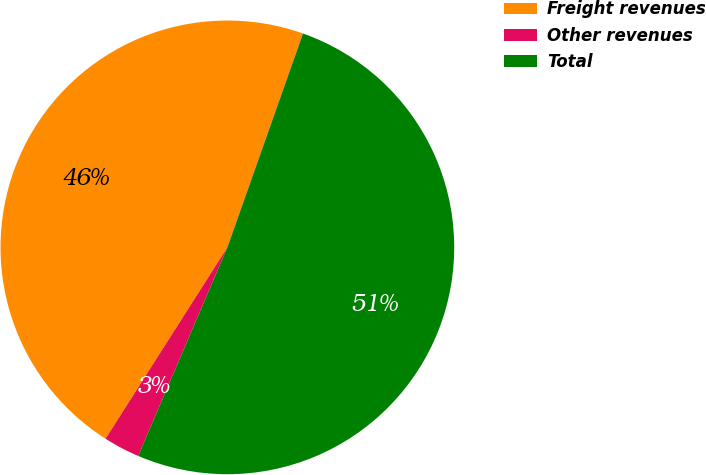Convert chart. <chart><loc_0><loc_0><loc_500><loc_500><pie_chart><fcel>Freight revenues<fcel>Other revenues<fcel>Total<nl><fcel>46.39%<fcel>2.59%<fcel>51.03%<nl></chart> 